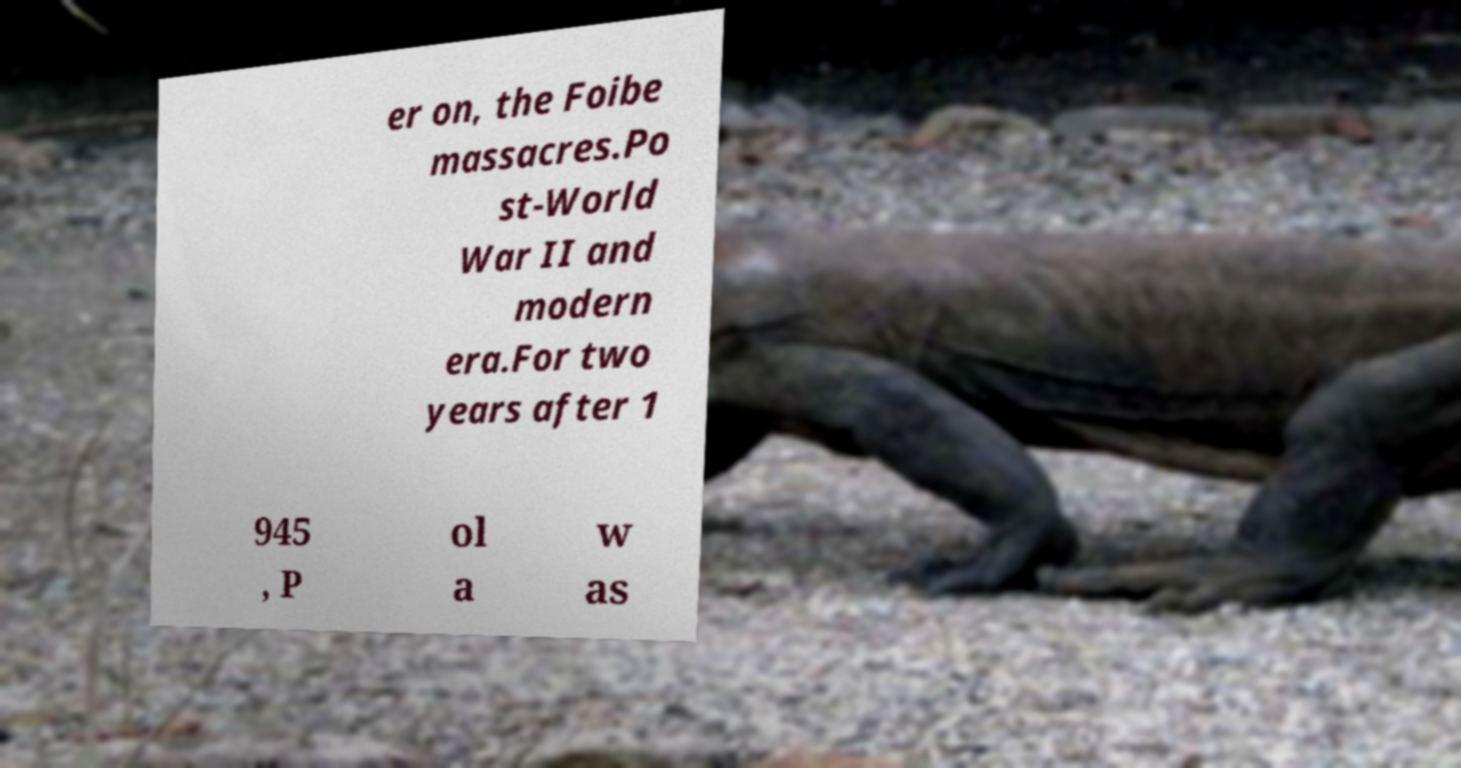Can you accurately transcribe the text from the provided image for me? er on, the Foibe massacres.Po st-World War II and modern era.For two years after 1 945 , P ol a w as 